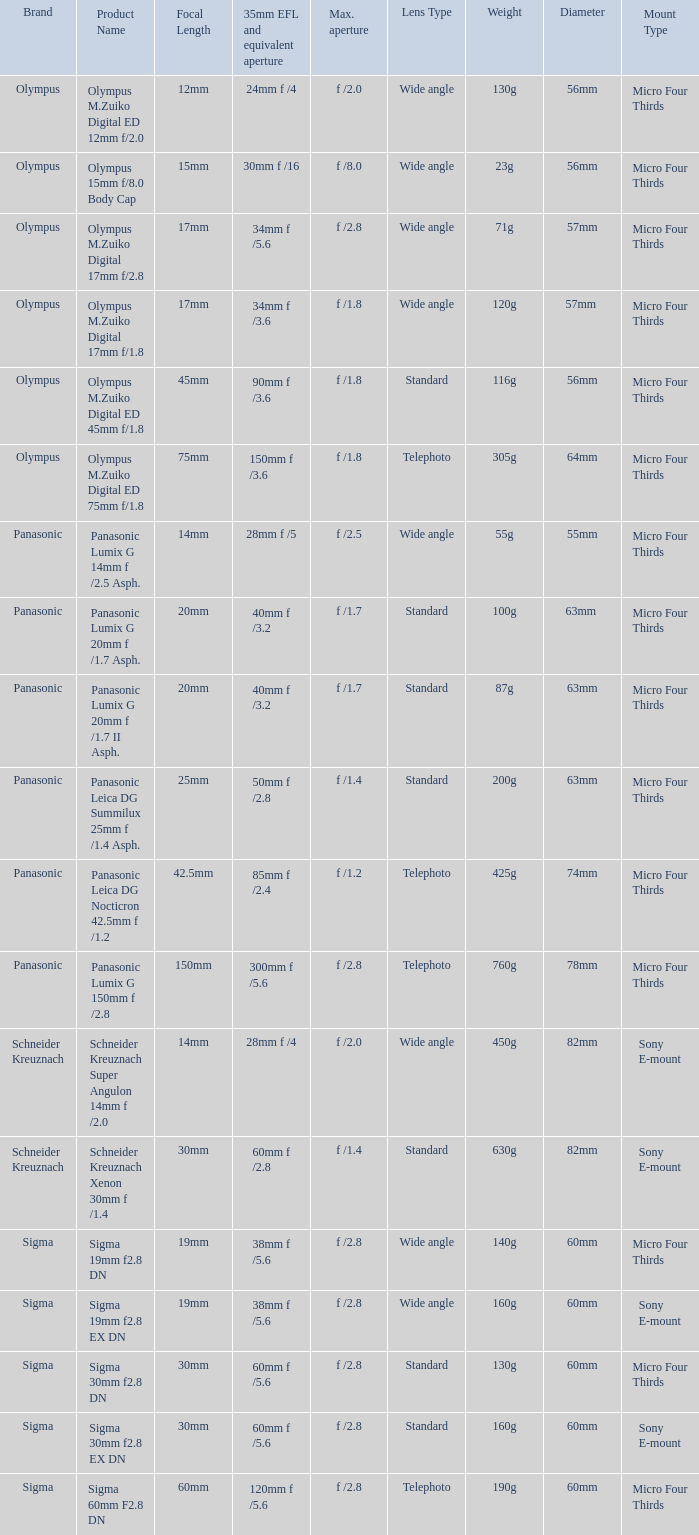What is the maximum aperture of the lens(es) with a focal length of 20mm? F /1.7, f /1.7. Could you help me parse every detail presented in this table? {'header': ['Brand', 'Product Name', 'Focal Length', '35mm EFL and equivalent aperture', 'Max. aperture', 'Lens Type', 'Weight', 'Diameter', 'Mount Type'], 'rows': [['Olympus', 'Olympus M.Zuiko Digital ED 12mm f/2.0', '12mm', '24mm f /4', 'f /2.0', 'Wide angle', '130g', '56mm', 'Micro Four Thirds'], ['Olympus', 'Olympus 15mm f/8.0 Body Cap', '15mm', '30mm f /16', 'f /8.0', 'Wide angle', '23g', '56mm', 'Micro Four Thirds'], ['Olympus', 'Olympus M.Zuiko Digital 17mm f/2.8', '17mm', '34mm f /5.6', 'f /2.8', 'Wide angle', '71g', '57mm', 'Micro Four Thirds'], ['Olympus', 'Olympus M.Zuiko Digital 17mm f/1.8', '17mm', '34mm f /3.6', 'f /1.8', 'Wide angle', '120g', '57mm ', 'Micro Four Thirds'], ['Olympus', 'Olympus M.Zuiko Digital ED 45mm f/1.8', '45mm', '90mm f /3.6', 'f /1.8', 'Standard', '116g', '56mm', 'Micro Four Thirds'], ['Olympus', 'Olympus M.Zuiko Digital ED 75mm f/1.8', '75mm', '150mm f /3.6', 'f /1.8', 'Telephoto', '305g', '64mm', 'Micro Four Thirds'], ['Panasonic', 'Panasonic Lumix G 14mm f /2.5 Asph.', '14mm', '28mm f /5', 'f /2.5', 'Wide angle', '55g', '55mm', 'Micro Four Thirds'], ['Panasonic', 'Panasonic Lumix G 20mm f /1.7 Asph.', '20mm', '40mm f /3.2', 'f /1.7', 'Standard', '100g', '63mm ', 'Micro Four Thirds'], ['Panasonic', 'Panasonic Lumix G 20mm f /1.7 II Asph.', '20mm', '40mm f /3.2', 'f /1.7', 'Standard', '87g', '63mm', 'Micro Four Thirds'], ['Panasonic', 'Panasonic Leica DG Summilux 25mm f /1.4 Asph.', '25mm', '50mm f /2.8', 'f /1.4', 'Standard', '200g', '63mm', 'Micro Four Thirds'], ['Panasonic', 'Panasonic Leica DG Nocticron 42.5mm f /1.2', '42.5mm', '85mm f /2.4', 'f /1.2', 'Telephoto', '425g', '74mm', 'Micro Four Thirds'], ['Panasonic', 'Panasonic Lumix G 150mm f /2.8', '150mm', '300mm f /5.6', 'f /2.8', 'Telephoto', '760g', '78mm', 'Micro Four Thirds'], ['Schneider Kreuznach', 'Schneider Kreuznach Super Angulon 14mm f /2.0', '14mm', '28mm f /4', 'f /2.0', 'Wide angle', '450g', '82mm', 'Sony E-mount'], ['Schneider Kreuznach', 'Schneider Kreuznach Xenon 30mm f /1.4', '30mm', '60mm f /2.8', 'f /1.4', 'Standard', '630g', '82mm', 'Sony E-mount'], ['Sigma', 'Sigma 19mm f2.8 DN', '19mm', '38mm f /5.6', 'f /2.8', 'Wide angle', '140g', '60mm', 'Micro Four Thirds'], ['Sigma', 'Sigma 19mm f2.8 EX DN', '19mm', '38mm f /5.6', 'f /2.8', 'Wide angle', '160g', '60mm', 'Sony E-mount'], ['Sigma', 'Sigma 30mm f2.8 DN', '30mm', '60mm f /5.6', 'f /2.8', 'Standard', '130g', '60mm', 'Micro Four Thirds'], ['Sigma', 'Sigma 30mm f2.8 EX DN', '30mm', '60mm f /5.6', 'f /2.8', 'Standard', '160g', '60mm', 'Sony E-mount'], ['Sigma', 'Sigma 60mm F2.8 DN', '60mm', '120mm f /5.6', 'f /2.8', 'Telephoto', '190g', '60mm', 'Micro Four Thirds']]} 